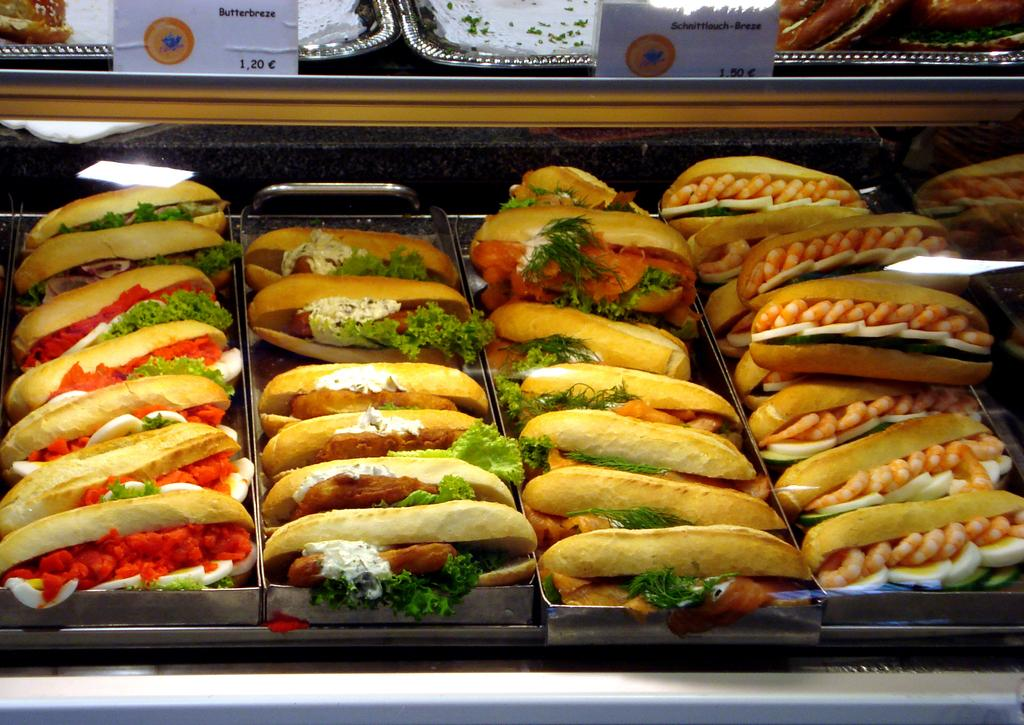What type of food is represented by the stuffed items in the image? There are stuffed hot dogs in the image. What can be seen at the top of the image? There are boards at the top of the image. What is located at the bottom of the image? There are trays at the bottom of the image. What type of harbor can be seen in the image? There is no harbor present in the image. What kind of vessel is being built by the carpenter in the image? There is no carpenter or vessel present in the image. 